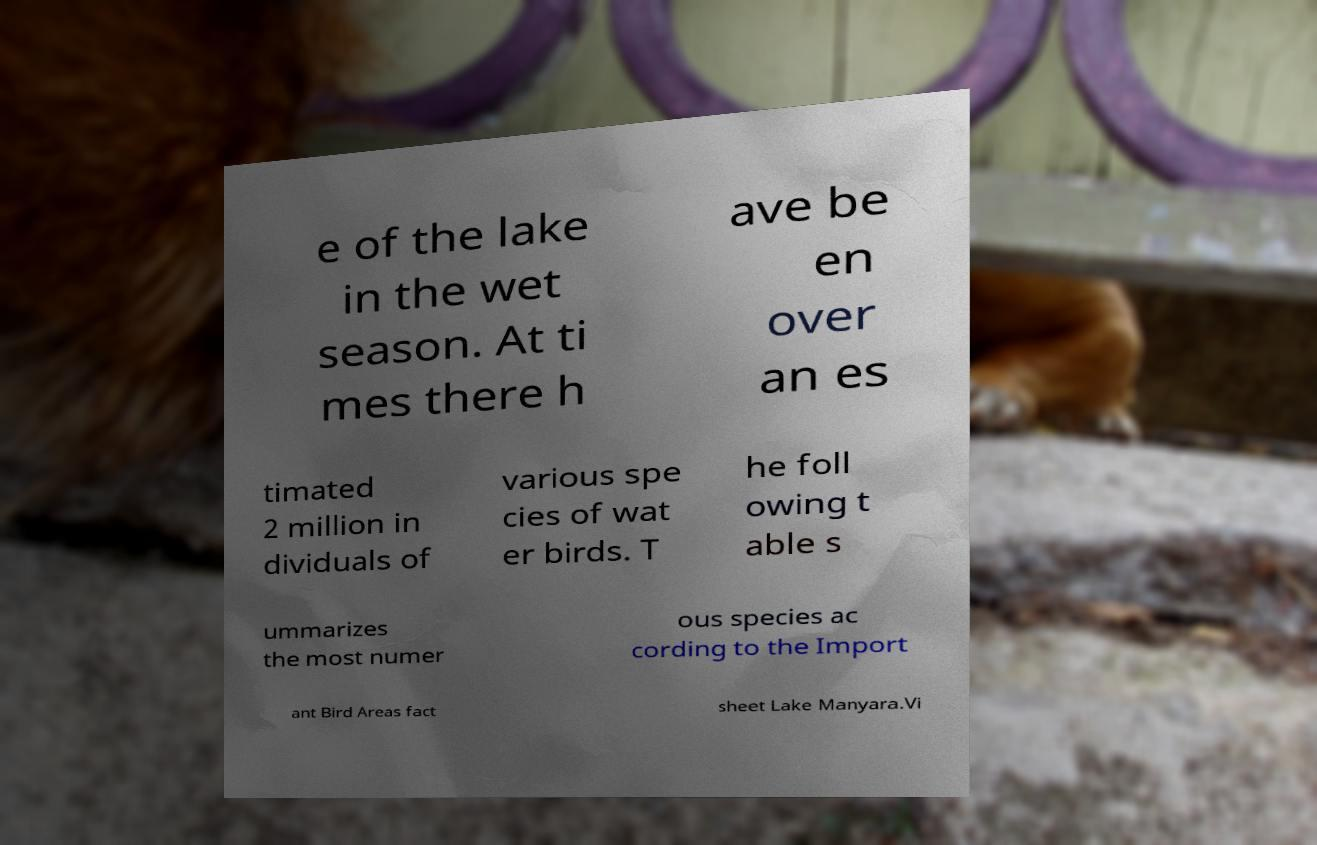For documentation purposes, I need the text within this image transcribed. Could you provide that? e of the lake in the wet season. At ti mes there h ave be en over an es timated 2 million in dividuals of various spe cies of wat er birds. T he foll owing t able s ummarizes the most numer ous species ac cording to the Import ant Bird Areas fact sheet Lake Manyara.Vi 